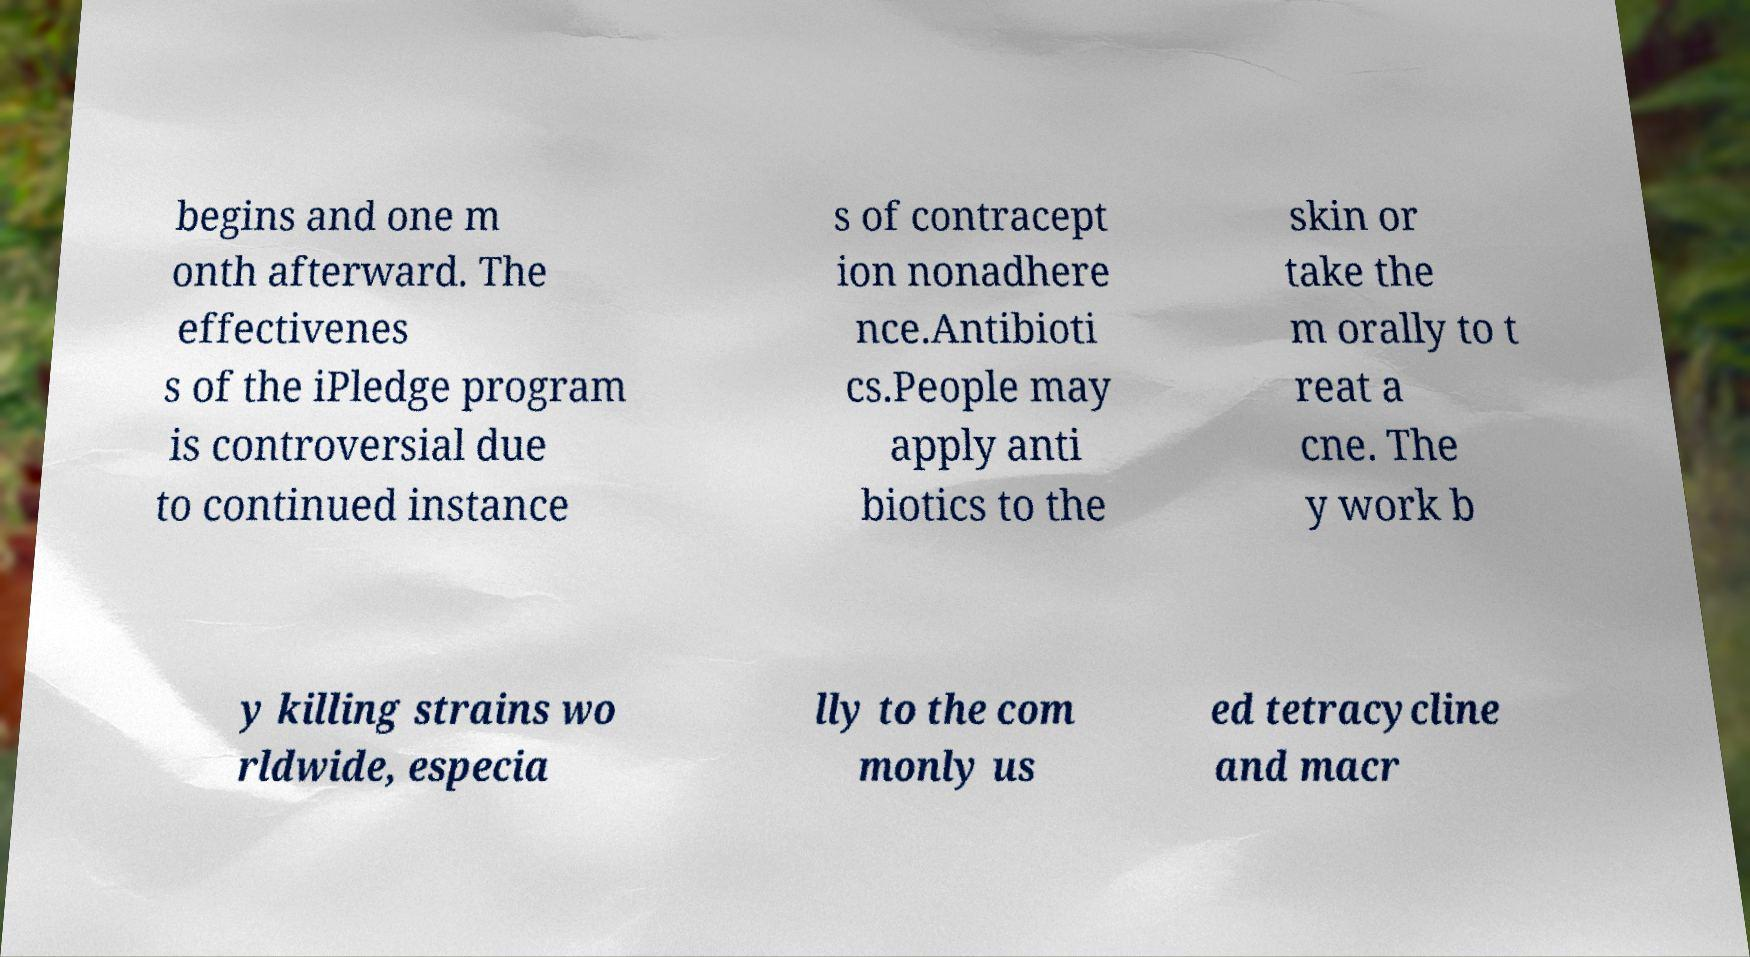There's text embedded in this image that I need extracted. Can you transcribe it verbatim? begins and one m onth afterward. The effectivenes s of the iPledge program is controversial due to continued instance s of contracept ion nonadhere nce.Antibioti cs.People may apply anti biotics to the skin or take the m orally to t reat a cne. The y work b y killing strains wo rldwide, especia lly to the com monly us ed tetracycline and macr 